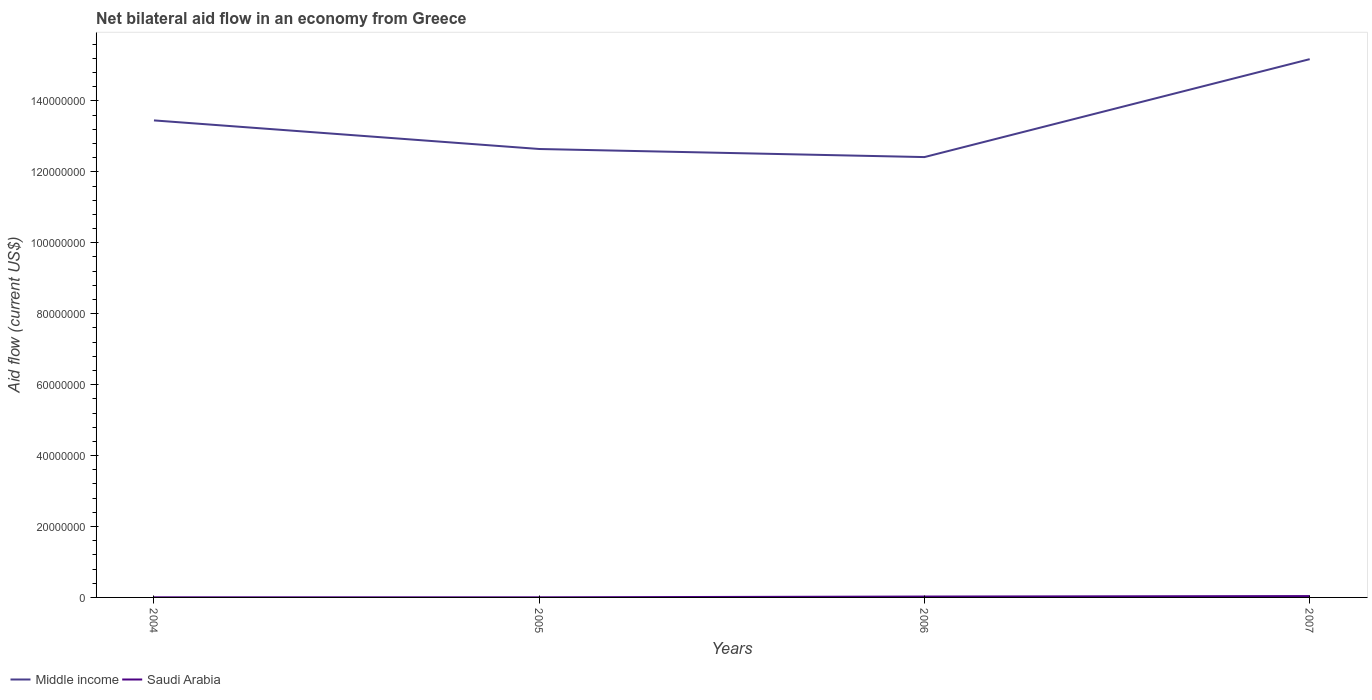How many different coloured lines are there?
Provide a succinct answer. 2. Does the line corresponding to Saudi Arabia intersect with the line corresponding to Middle income?
Your answer should be very brief. No. Across all years, what is the maximum net bilateral aid flow in Middle income?
Your answer should be compact. 1.24e+08. What is the total net bilateral aid flow in Middle income in the graph?
Your response must be concise. 2.28e+06. What is the difference between the highest and the second highest net bilateral aid flow in Middle income?
Make the answer very short. 2.76e+07. What is the difference between the highest and the lowest net bilateral aid flow in Middle income?
Your answer should be very brief. 2. Does the graph contain grids?
Give a very brief answer. No. Where does the legend appear in the graph?
Provide a short and direct response. Bottom left. How many legend labels are there?
Offer a terse response. 2. How are the legend labels stacked?
Offer a very short reply. Horizontal. What is the title of the graph?
Offer a terse response. Net bilateral aid flow in an economy from Greece. Does "Montenegro" appear as one of the legend labels in the graph?
Provide a short and direct response. No. What is the Aid flow (current US$) of Middle income in 2004?
Provide a short and direct response. 1.34e+08. What is the Aid flow (current US$) in Middle income in 2005?
Your response must be concise. 1.26e+08. What is the Aid flow (current US$) in Middle income in 2006?
Keep it short and to the point. 1.24e+08. What is the Aid flow (current US$) in Saudi Arabia in 2006?
Offer a very short reply. 2.50e+05. What is the Aid flow (current US$) of Middle income in 2007?
Provide a short and direct response. 1.52e+08. Across all years, what is the maximum Aid flow (current US$) of Middle income?
Offer a very short reply. 1.52e+08. Across all years, what is the maximum Aid flow (current US$) of Saudi Arabia?
Your answer should be compact. 3.80e+05. Across all years, what is the minimum Aid flow (current US$) of Middle income?
Make the answer very short. 1.24e+08. What is the total Aid flow (current US$) in Middle income in the graph?
Your response must be concise. 5.37e+08. What is the total Aid flow (current US$) in Saudi Arabia in the graph?
Offer a very short reply. 6.90e+05. What is the difference between the Aid flow (current US$) of Middle income in 2004 and that in 2005?
Provide a succinct answer. 8.06e+06. What is the difference between the Aid flow (current US$) in Saudi Arabia in 2004 and that in 2005?
Make the answer very short. 0. What is the difference between the Aid flow (current US$) of Middle income in 2004 and that in 2006?
Give a very brief answer. 1.03e+07. What is the difference between the Aid flow (current US$) in Middle income in 2004 and that in 2007?
Your answer should be compact. -1.73e+07. What is the difference between the Aid flow (current US$) in Saudi Arabia in 2004 and that in 2007?
Your answer should be very brief. -3.50e+05. What is the difference between the Aid flow (current US$) in Middle income in 2005 and that in 2006?
Keep it short and to the point. 2.28e+06. What is the difference between the Aid flow (current US$) of Saudi Arabia in 2005 and that in 2006?
Make the answer very short. -2.20e+05. What is the difference between the Aid flow (current US$) in Middle income in 2005 and that in 2007?
Offer a very short reply. -2.53e+07. What is the difference between the Aid flow (current US$) in Saudi Arabia in 2005 and that in 2007?
Ensure brevity in your answer.  -3.50e+05. What is the difference between the Aid flow (current US$) in Middle income in 2006 and that in 2007?
Provide a short and direct response. -2.76e+07. What is the difference between the Aid flow (current US$) in Middle income in 2004 and the Aid flow (current US$) in Saudi Arabia in 2005?
Your response must be concise. 1.34e+08. What is the difference between the Aid flow (current US$) in Middle income in 2004 and the Aid flow (current US$) in Saudi Arabia in 2006?
Keep it short and to the point. 1.34e+08. What is the difference between the Aid flow (current US$) in Middle income in 2004 and the Aid flow (current US$) in Saudi Arabia in 2007?
Your response must be concise. 1.34e+08. What is the difference between the Aid flow (current US$) of Middle income in 2005 and the Aid flow (current US$) of Saudi Arabia in 2006?
Your answer should be very brief. 1.26e+08. What is the difference between the Aid flow (current US$) of Middle income in 2005 and the Aid flow (current US$) of Saudi Arabia in 2007?
Your answer should be compact. 1.26e+08. What is the difference between the Aid flow (current US$) of Middle income in 2006 and the Aid flow (current US$) of Saudi Arabia in 2007?
Your response must be concise. 1.24e+08. What is the average Aid flow (current US$) in Middle income per year?
Provide a succinct answer. 1.34e+08. What is the average Aid flow (current US$) in Saudi Arabia per year?
Offer a very short reply. 1.72e+05. In the year 2004, what is the difference between the Aid flow (current US$) in Middle income and Aid flow (current US$) in Saudi Arabia?
Keep it short and to the point. 1.34e+08. In the year 2005, what is the difference between the Aid flow (current US$) in Middle income and Aid flow (current US$) in Saudi Arabia?
Your response must be concise. 1.26e+08. In the year 2006, what is the difference between the Aid flow (current US$) in Middle income and Aid flow (current US$) in Saudi Arabia?
Your answer should be compact. 1.24e+08. In the year 2007, what is the difference between the Aid flow (current US$) in Middle income and Aid flow (current US$) in Saudi Arabia?
Provide a short and direct response. 1.51e+08. What is the ratio of the Aid flow (current US$) in Middle income in 2004 to that in 2005?
Provide a short and direct response. 1.06. What is the ratio of the Aid flow (current US$) in Saudi Arabia in 2004 to that in 2005?
Make the answer very short. 1. What is the ratio of the Aid flow (current US$) of Middle income in 2004 to that in 2006?
Your answer should be compact. 1.08. What is the ratio of the Aid flow (current US$) of Saudi Arabia in 2004 to that in 2006?
Provide a short and direct response. 0.12. What is the ratio of the Aid flow (current US$) of Middle income in 2004 to that in 2007?
Your answer should be compact. 0.89. What is the ratio of the Aid flow (current US$) in Saudi Arabia in 2004 to that in 2007?
Give a very brief answer. 0.08. What is the ratio of the Aid flow (current US$) of Middle income in 2005 to that in 2006?
Provide a short and direct response. 1.02. What is the ratio of the Aid flow (current US$) of Saudi Arabia in 2005 to that in 2006?
Provide a succinct answer. 0.12. What is the ratio of the Aid flow (current US$) of Middle income in 2005 to that in 2007?
Keep it short and to the point. 0.83. What is the ratio of the Aid flow (current US$) in Saudi Arabia in 2005 to that in 2007?
Your answer should be compact. 0.08. What is the ratio of the Aid flow (current US$) in Middle income in 2006 to that in 2007?
Provide a short and direct response. 0.82. What is the ratio of the Aid flow (current US$) in Saudi Arabia in 2006 to that in 2007?
Offer a terse response. 0.66. What is the difference between the highest and the second highest Aid flow (current US$) in Middle income?
Make the answer very short. 1.73e+07. What is the difference between the highest and the second highest Aid flow (current US$) in Saudi Arabia?
Ensure brevity in your answer.  1.30e+05. What is the difference between the highest and the lowest Aid flow (current US$) in Middle income?
Offer a very short reply. 2.76e+07. What is the difference between the highest and the lowest Aid flow (current US$) in Saudi Arabia?
Your answer should be very brief. 3.50e+05. 